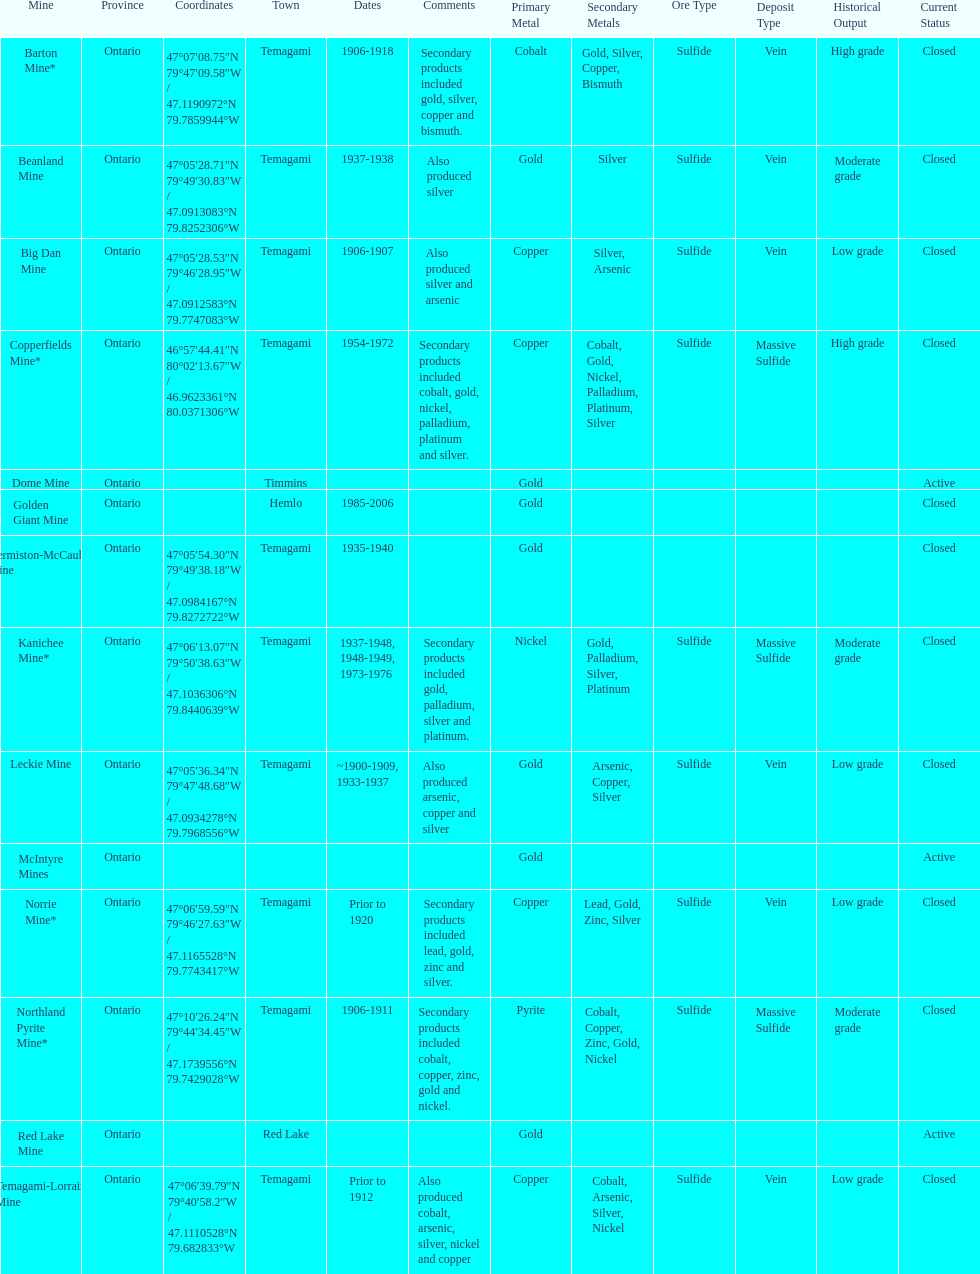Which mine was open longer, golden giant or beanland mine? Golden Giant Mine. 